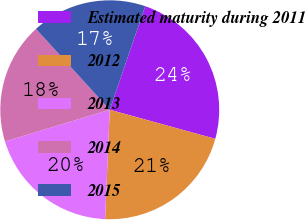Convert chart to OTSL. <chart><loc_0><loc_0><loc_500><loc_500><pie_chart><fcel>Estimated maturity during 2011<fcel>2012<fcel>2013<fcel>2014<fcel>2015<nl><fcel>24.02%<fcel>21.4%<fcel>19.65%<fcel>17.9%<fcel>17.03%<nl></chart> 